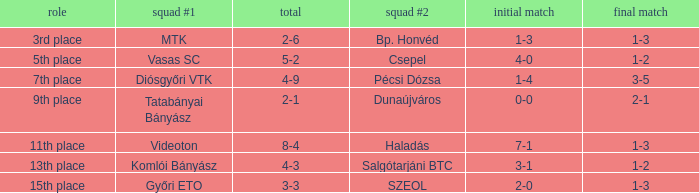What is the 1st leg of bp. honvéd team #2? 1-3. 